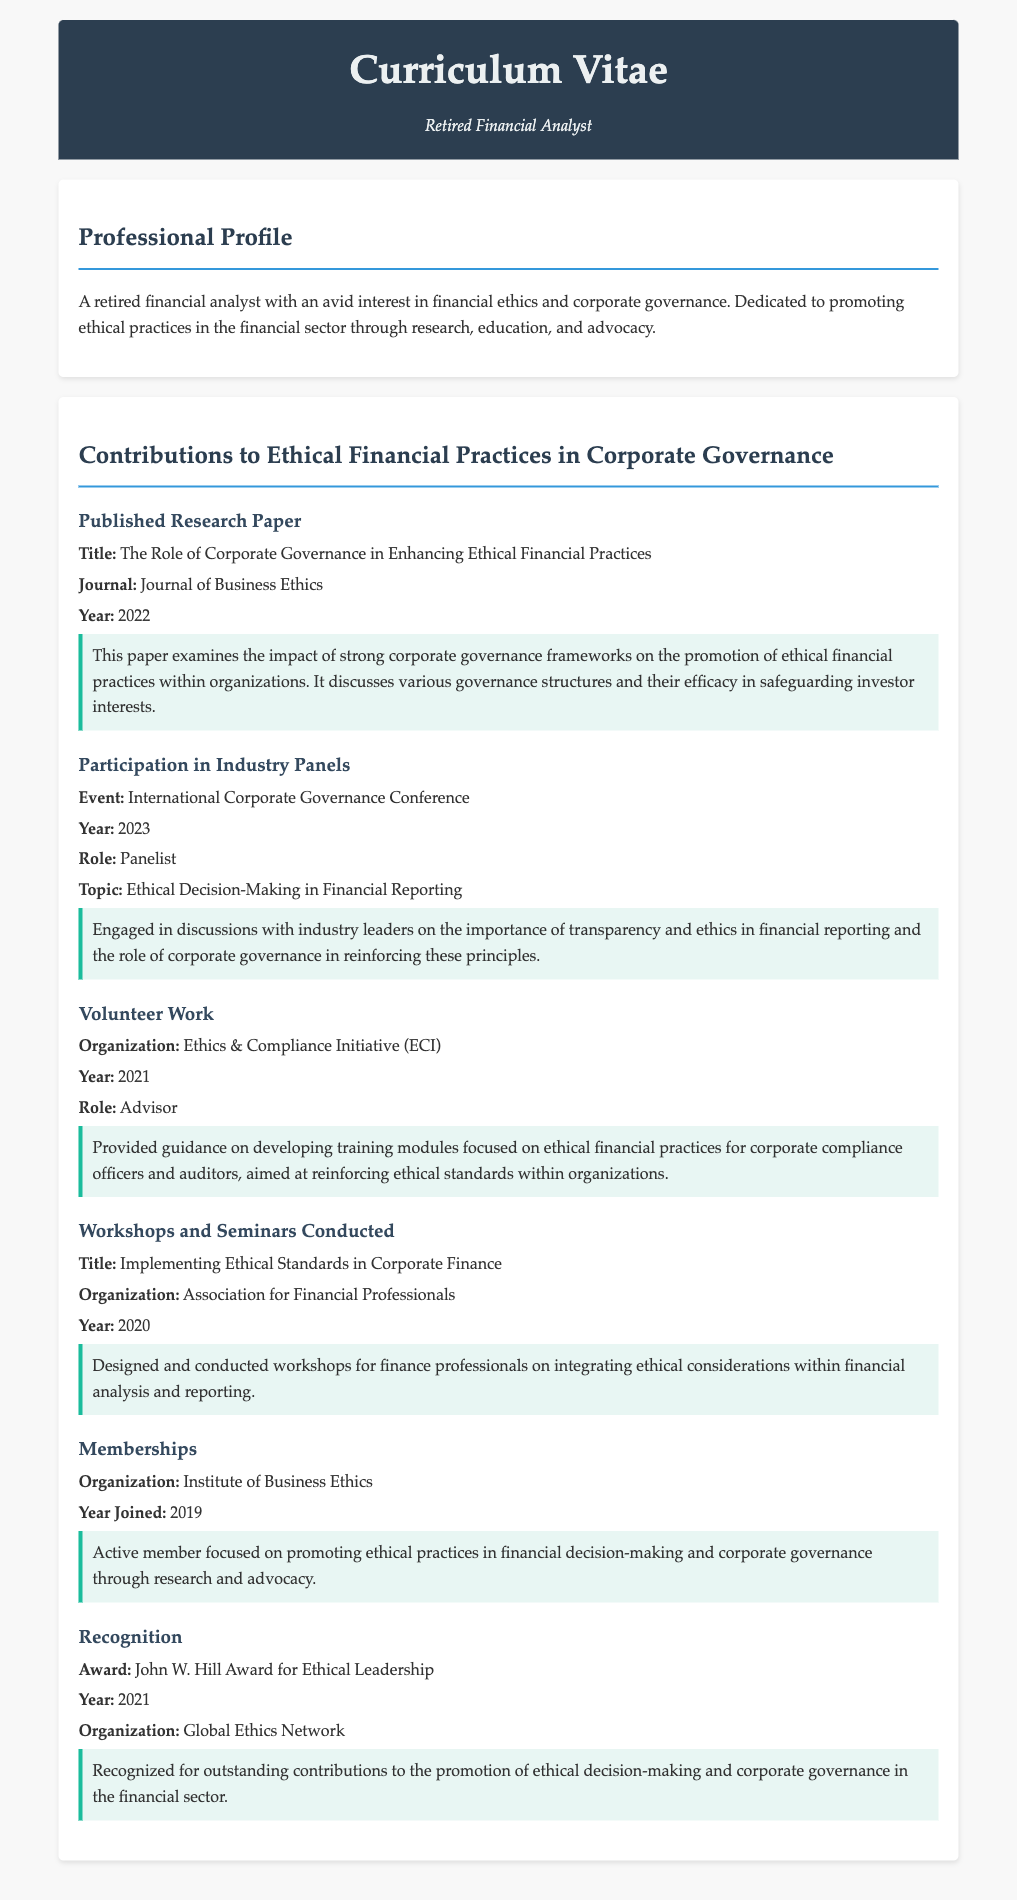what is the title of the published research paper? The title of the published research paper is explicitly stated in the CV section on contributions, which is "The Role of Corporate Governance in Enhancing Ethical Financial Practices."
Answer: The Role of Corporate Governance in Enhancing Ethical Financial Practices what year was the paper published? The year of publication for the paper is provided in the document, which states it was published in 2022.
Answer: 2022 who was the panelist at the International Corporate Governance Conference? The document identifies the individual as the retired financial analyst presenting on the topic, thus confirming their role as a panelist.
Answer: Retired Financial Analyst what organization did the individual volunteer for? The CV mentions that the individual volunteered with the Ethics & Compliance Initiative (ECI).
Answer: Ethics & Compliance Initiative (ECI) what was the focus of the workshops and seminars conducted? The focus of the workshops is summarized in the title mentioned in the document, which indicates their content regarding ethical standards in corporate finance.
Answer: Implementing Ethical Standards in Corporate Finance which award was received for ethical leadership? The CV explicitly states the award received as the John W. Hill Award for Ethical Leadership.
Answer: John W. Hill Award for Ethical Leadership in what year was the individual recognized with the John W. Hill Award? The recognition is detailed in the CV, stating that it was awarded in 2021.
Answer: 2021 what organization is the individual a member of? The institution where the individual holds active membership is specifically noted in the contributions section, confirming their engagement in promoting ethical practices.
Answer: Institute of Business Ethics what topic was discussed at the panel where the individual participated? The topic of discussion at the panel is explicitly given, which relates to ethical decision-making in financial reporting.
Answer: Ethical Decision-Making in Financial Reporting 